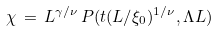<formula> <loc_0><loc_0><loc_500><loc_500>\chi \, = \, L ^ { \gamma / \nu } \, P ( t ( L / \xi _ { 0 } ) ^ { 1 / \nu } , \Lambda L )</formula> 